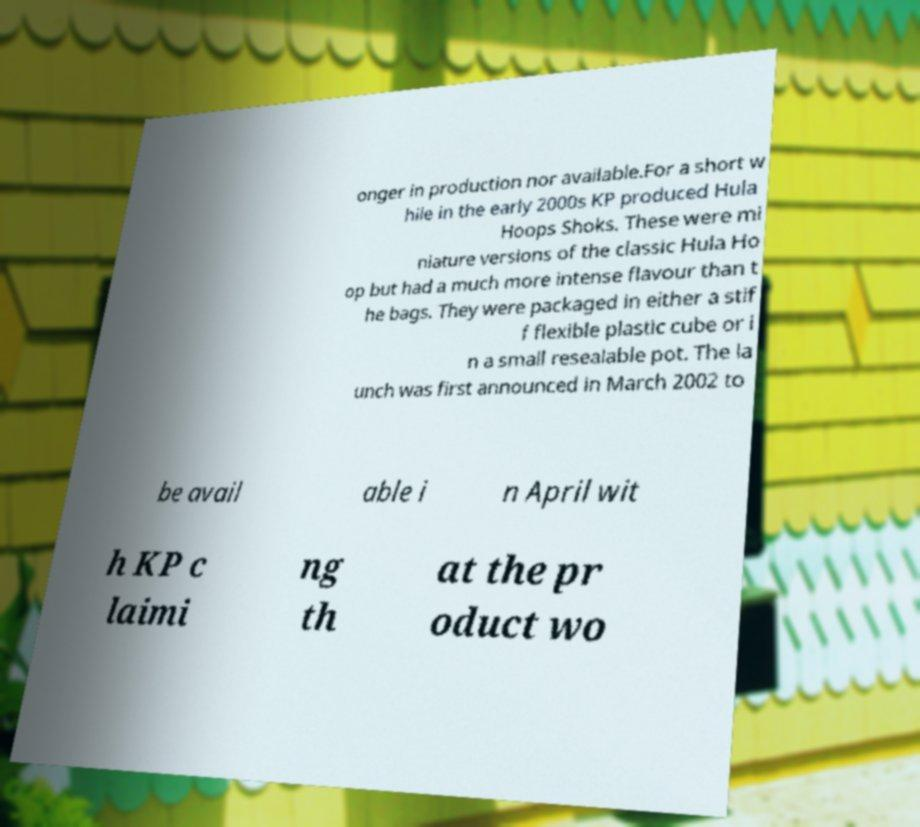Could you extract and type out the text from this image? onger in production nor available.For a short w hile in the early 2000s KP produced Hula Hoops Shoks. These were mi niature versions of the classic Hula Ho op but had a much more intense flavour than t he bags. They were packaged in either a stif f flexible plastic cube or i n a small resealable pot. The la unch was first announced in March 2002 to be avail able i n April wit h KP c laimi ng th at the pr oduct wo 